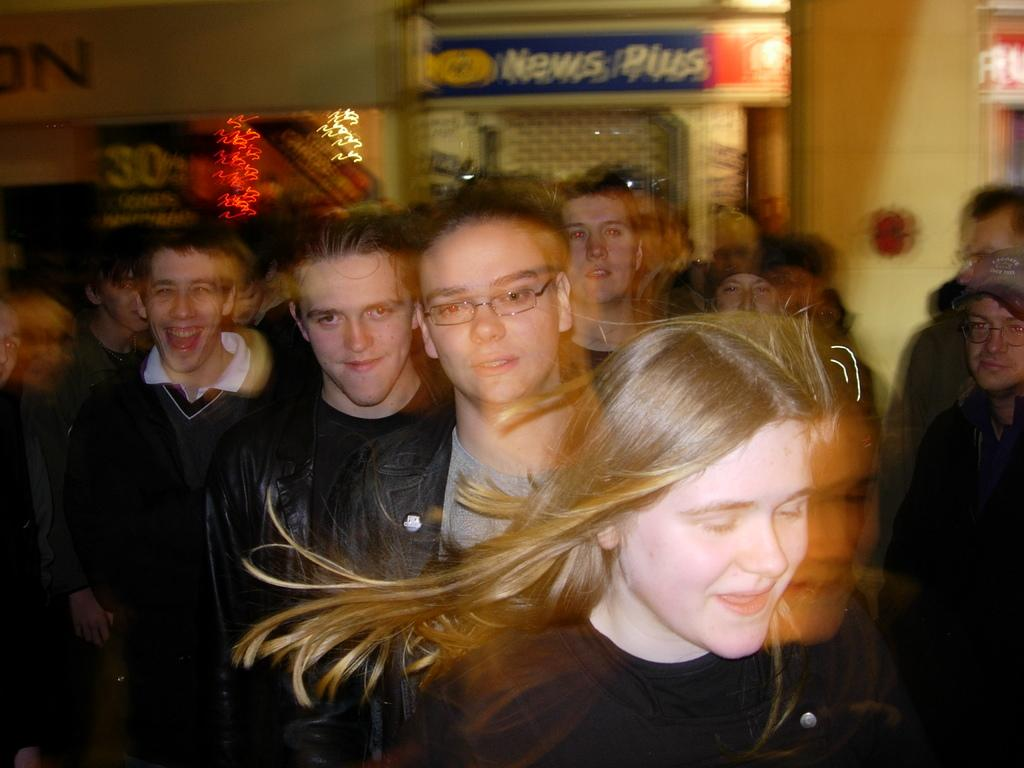What is happening in the image? There are people standing in the image. What can be seen in the background of the image? There is a wall in the background of the image. What is on the wall in the image? There are posters on the wall. What type of quince is being used as a decoration in the image? There is no quince present in the image; it features people standing and posters on a wall. 